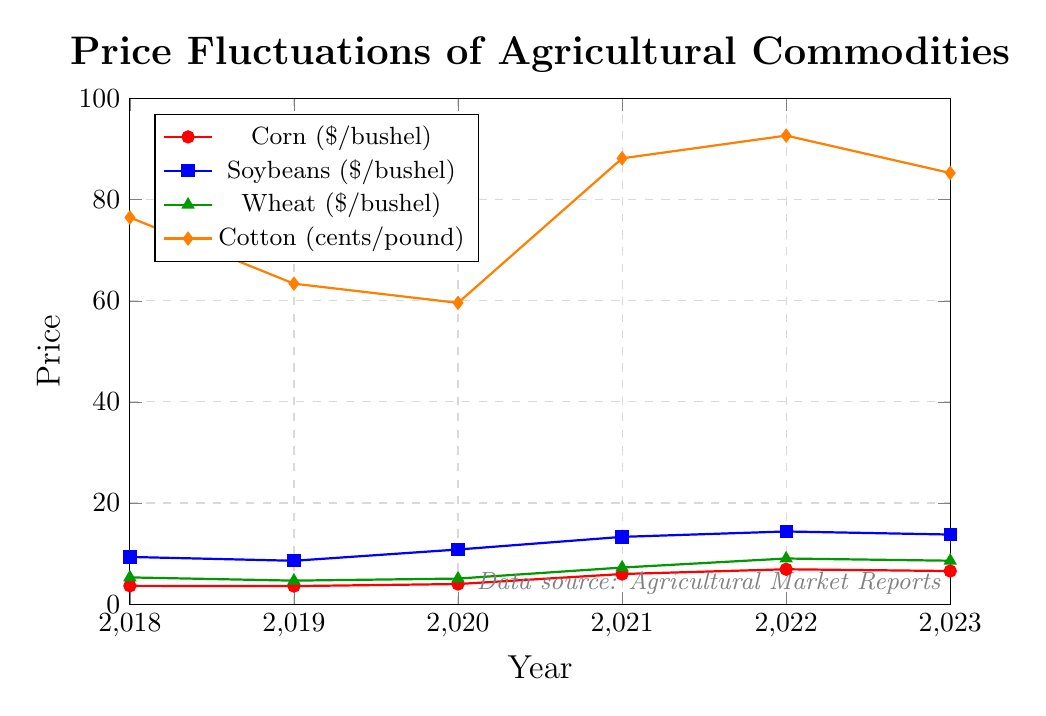What's the trend of corn prices from 2018 to 2023? Corn prices start from $3.61 per bushel in 2018, slightly decrease in 2019, then gradually increase each year, peaking at $6.89 in 2022, and slightly decrease in 2023 to $6.54.
Answer: They generally increase Which commodity had the highest price increase percentage from 2018 to 2023? Calculate percentage increase for each commodity: Corn (6.54-3.61)/3.61 ≈ 81.2%, Soybeans (13.76-9.33)/9.33 ≈ 47.5%, Wheat (8.58-5.28)/5.28 ≈ 62.5%, Cotton (85.3-76.5)/76.5 ≈ 11.5%
Answer: Corn What was the price of wheat in 2021? Locate the wheat data for the year 2021 on the plot.
Answer: $7.23 per bushel Between which consecutive years did soybeans experience the highest price increase? Check the difference year over year: 2018-2019 (-0.76), 2019-2020 (+2.23), 2020-2021 (+2.50), 2021-2022 (+1.07), 2022-2023 (-0.61). The highest increase occurred between 2020 and 2021 with an increase of $2.50 per bushel.
Answer: 2020 to 2021 Which year had the lowest cotton price, and what was it? Locate the lowest point of the cotton line on the chart, which is in 2020 at 59.6 cents per pound.
Answer: 2020, 59.6 cents per pound How did the price of soybeans change from 2019 to 2023? Soybeans:$8.57 (2019), $10.80 (2020), $13.30 (2021), $14.37 (2022), $13.76 (2023). The prices increased initially from 2019 to 2022, then slightly decreased in 2023.
Answer: It increased and then slightly decreased What is the average price of corn from 2019 to 2022? Sum the corn prices from 2019 to 2022 and divide by the number of years: (3.56 + 3.97 + 5.95 + 6.89)/4.
Answer: $5.09 per bushel Compare the prices of soybeans and corn in 2022. Which one is higher and by how much? Cost of soybeans is $14.37 and corn is $6.89. Difference: $14.37 - $6.89 = $7.48
Answer: Soybeans are $7.48 higher What is the trend of wheat prices from 2018 to 2021? The price of wheat decreases from $5.28 in 2018 to $4.64 in 2019, increases to $5.05 in 2020, and further up to $7.23 in 2021.
Answer: Decrease, then increase 